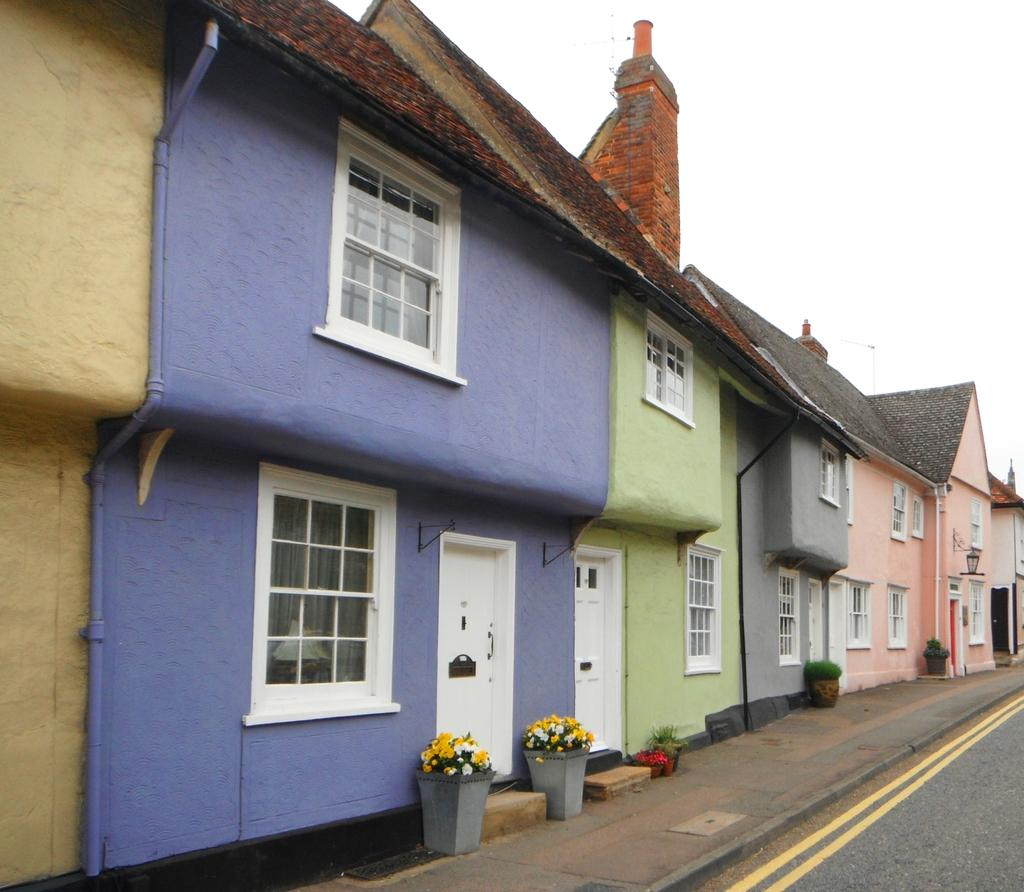What type of structures can be seen in the image? There are houses in the image. What type of plants are present in the image? There are potted plants in the image. What type of flora is visible in the image? There are flowers in the image. What architectural features can be seen on the houses? There are windows and doors in the image. What type of illumination is present in the image? There is a light in the image. What can be seen in the background of the image? The sky is visible in the background of the image. What type of furniture is visible in the image? There is no furniture present in the image. What type of appliance can be seen in the image? There is no appliance present in the image. 